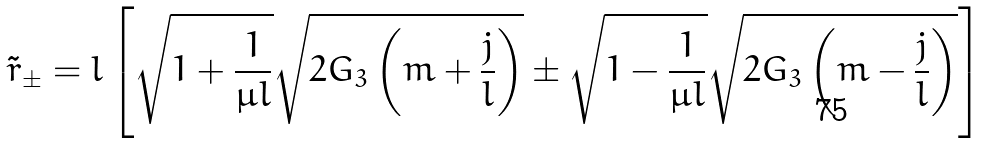Convert formula to latex. <formula><loc_0><loc_0><loc_500><loc_500>\tilde { r } _ { \pm } = l \left [ \sqrt { 1 + \frac { 1 } { \mu l } } \sqrt { 2 G _ { 3 } \left ( m + \frac { j } { l } \right ) } \pm \sqrt { 1 - \frac { 1 } { \mu l } } \sqrt { 2 G _ { 3 } \left ( m - \frac { j } { l } \right ) } \right ]</formula> 